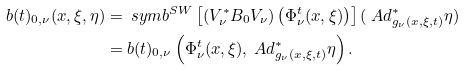Convert formula to latex. <formula><loc_0><loc_0><loc_500><loc_500>b ( t ) _ { 0 , \nu } ( x , \xi , \eta ) & = \ s y m b ^ { S W } \left [ \left ( V _ { \nu } ^ { \ast } B _ { 0 } V _ { \nu } \right ) \left ( \Phi ^ { t } _ { \nu } ( x , \xi ) \right ) \right ] ( \ A d ^ { \ast } _ { g _ { \nu } ( x , \xi , t ) } \eta ) \\ & = b ( t ) _ { 0 , \nu } \left ( \Phi ^ { t } _ { \nu } ( x , \xi ) , \ A d ^ { \ast } _ { g _ { \nu } ( x , \xi , t ) } \eta \right ) .</formula> 